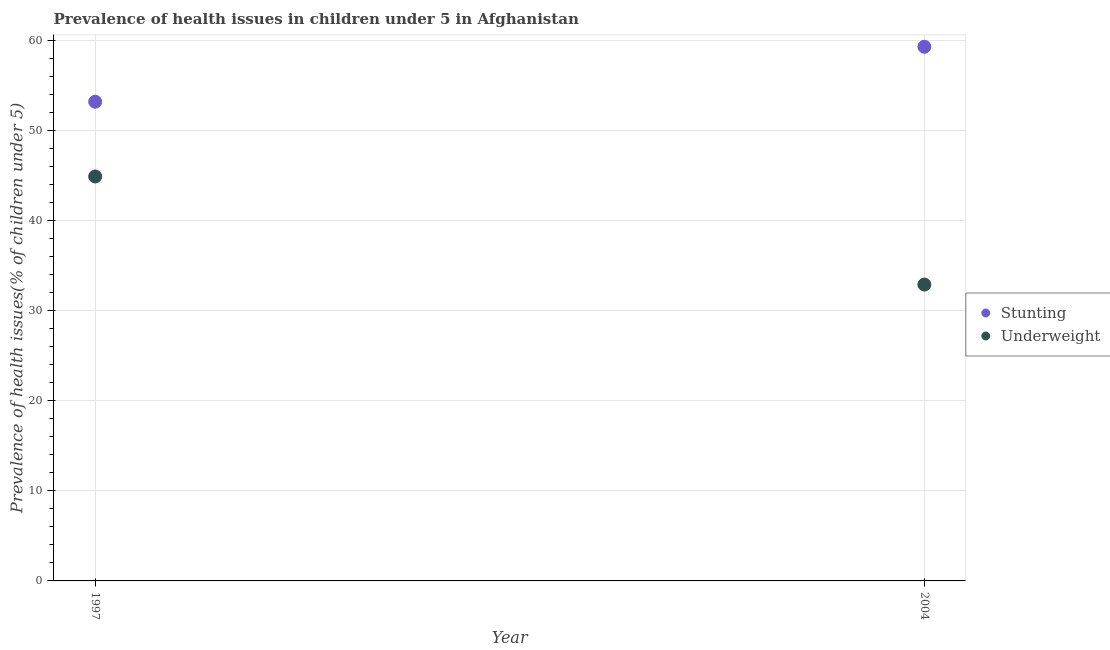Is the number of dotlines equal to the number of legend labels?
Provide a short and direct response. Yes. What is the percentage of stunted children in 1997?
Ensure brevity in your answer.  53.2. Across all years, what is the maximum percentage of stunted children?
Provide a succinct answer. 59.3. Across all years, what is the minimum percentage of underweight children?
Your response must be concise. 32.9. In which year was the percentage of underweight children minimum?
Give a very brief answer. 2004. What is the total percentage of stunted children in the graph?
Provide a succinct answer. 112.5. What is the difference between the percentage of stunted children in 1997 and that in 2004?
Make the answer very short. -6.1. What is the difference between the percentage of underweight children in 1997 and the percentage of stunted children in 2004?
Provide a short and direct response. -14.4. What is the average percentage of stunted children per year?
Ensure brevity in your answer.  56.25. In the year 1997, what is the difference between the percentage of underweight children and percentage of stunted children?
Keep it short and to the point. -8.3. In how many years, is the percentage of stunted children greater than 4 %?
Your answer should be very brief. 2. What is the ratio of the percentage of stunted children in 1997 to that in 2004?
Give a very brief answer. 0.9. Is the percentage of underweight children in 1997 less than that in 2004?
Your response must be concise. No. In how many years, is the percentage of underweight children greater than the average percentage of underweight children taken over all years?
Keep it short and to the point. 1. Is the percentage of stunted children strictly greater than the percentage of underweight children over the years?
Provide a succinct answer. Yes. Is the percentage of stunted children strictly less than the percentage of underweight children over the years?
Give a very brief answer. No. Does the graph contain grids?
Ensure brevity in your answer.  Yes. Where does the legend appear in the graph?
Offer a terse response. Center right. How many legend labels are there?
Make the answer very short. 2. What is the title of the graph?
Make the answer very short. Prevalence of health issues in children under 5 in Afghanistan. What is the label or title of the X-axis?
Offer a terse response. Year. What is the label or title of the Y-axis?
Offer a terse response. Prevalence of health issues(% of children under 5). What is the Prevalence of health issues(% of children under 5) in Stunting in 1997?
Make the answer very short. 53.2. What is the Prevalence of health issues(% of children under 5) in Underweight in 1997?
Your answer should be compact. 44.9. What is the Prevalence of health issues(% of children under 5) of Stunting in 2004?
Your response must be concise. 59.3. What is the Prevalence of health issues(% of children under 5) in Underweight in 2004?
Your response must be concise. 32.9. Across all years, what is the maximum Prevalence of health issues(% of children under 5) of Stunting?
Provide a short and direct response. 59.3. Across all years, what is the maximum Prevalence of health issues(% of children under 5) in Underweight?
Provide a short and direct response. 44.9. Across all years, what is the minimum Prevalence of health issues(% of children under 5) of Stunting?
Give a very brief answer. 53.2. Across all years, what is the minimum Prevalence of health issues(% of children under 5) of Underweight?
Ensure brevity in your answer.  32.9. What is the total Prevalence of health issues(% of children under 5) in Stunting in the graph?
Provide a succinct answer. 112.5. What is the total Prevalence of health issues(% of children under 5) in Underweight in the graph?
Your answer should be very brief. 77.8. What is the difference between the Prevalence of health issues(% of children under 5) of Underweight in 1997 and that in 2004?
Your answer should be very brief. 12. What is the difference between the Prevalence of health issues(% of children under 5) of Stunting in 1997 and the Prevalence of health issues(% of children under 5) of Underweight in 2004?
Keep it short and to the point. 20.3. What is the average Prevalence of health issues(% of children under 5) in Stunting per year?
Your response must be concise. 56.25. What is the average Prevalence of health issues(% of children under 5) of Underweight per year?
Give a very brief answer. 38.9. In the year 1997, what is the difference between the Prevalence of health issues(% of children under 5) of Stunting and Prevalence of health issues(% of children under 5) of Underweight?
Offer a terse response. 8.3. In the year 2004, what is the difference between the Prevalence of health issues(% of children under 5) of Stunting and Prevalence of health issues(% of children under 5) of Underweight?
Offer a terse response. 26.4. What is the ratio of the Prevalence of health issues(% of children under 5) of Stunting in 1997 to that in 2004?
Offer a terse response. 0.9. What is the ratio of the Prevalence of health issues(% of children under 5) of Underweight in 1997 to that in 2004?
Provide a succinct answer. 1.36. What is the difference between the highest and the second highest Prevalence of health issues(% of children under 5) of Underweight?
Your answer should be very brief. 12. What is the difference between the highest and the lowest Prevalence of health issues(% of children under 5) of Stunting?
Provide a succinct answer. 6.1. 